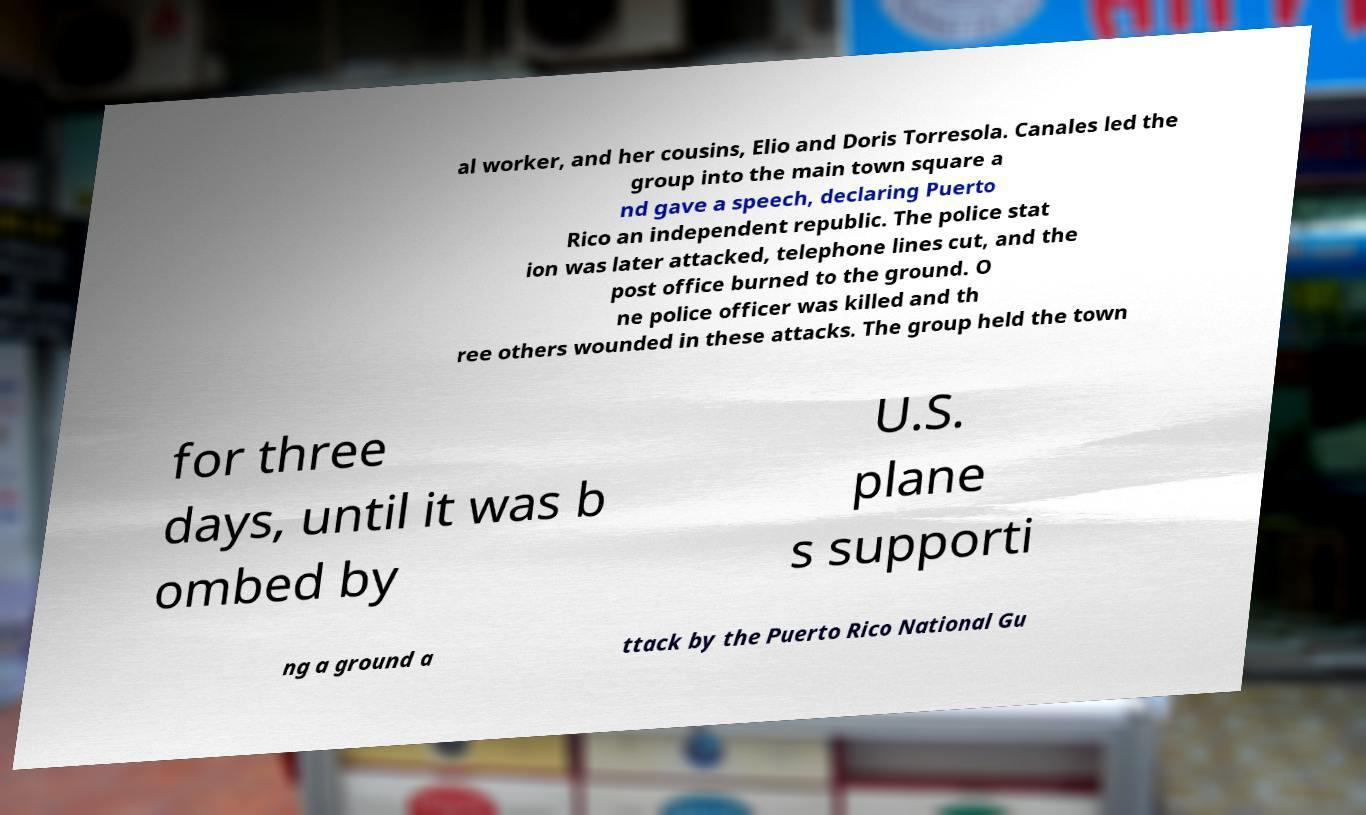Could you assist in decoding the text presented in this image and type it out clearly? al worker, and her cousins, Elio and Doris Torresola. Canales led the group into the main town square a nd gave a speech, declaring Puerto Rico an independent republic. The police stat ion was later attacked, telephone lines cut, and the post office burned to the ground. O ne police officer was killed and th ree others wounded in these attacks. The group held the town for three days, until it was b ombed by U.S. plane s supporti ng a ground a ttack by the Puerto Rico National Gu 